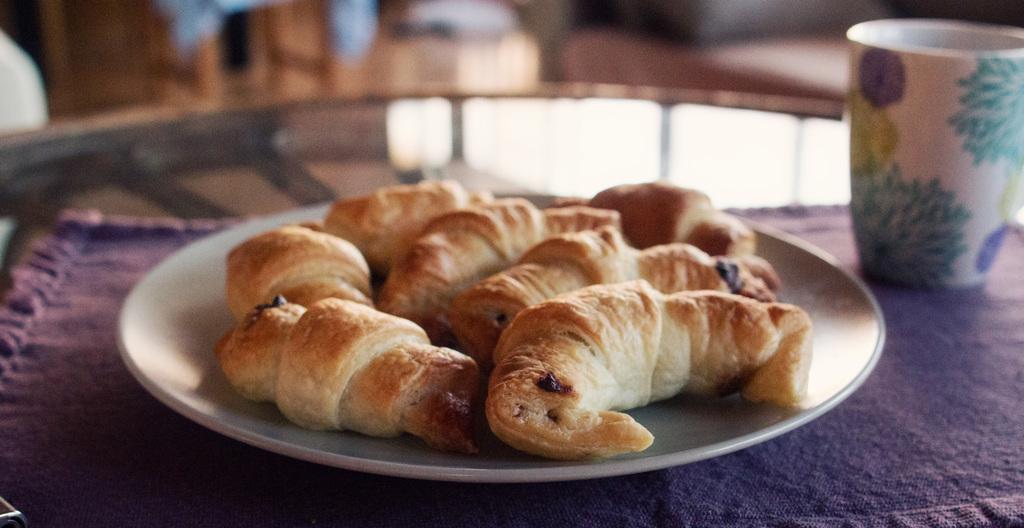Could you give a brief overview of what you see in this image? In this image I can see a plate, a glass, a purple colour cloth and cream colour food over here. I can also see this image is little bit blurry from background. 